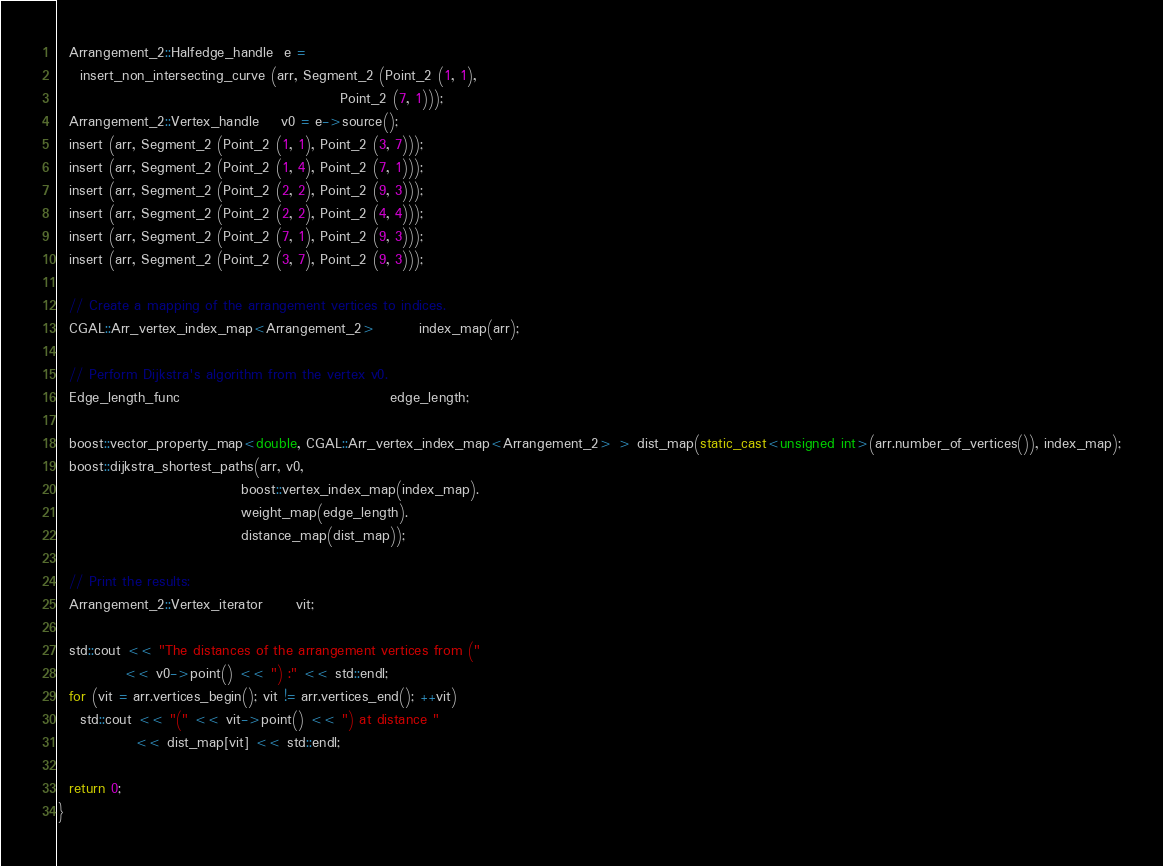<code> <loc_0><loc_0><loc_500><loc_500><_C++_>  Arrangement_2::Halfedge_handle  e =
    insert_non_intersecting_curve (arr, Segment_2 (Point_2 (1, 1),
                                                   Point_2 (7, 1)));
  Arrangement_2::Vertex_handle    v0 = e->source();
  insert (arr, Segment_2 (Point_2 (1, 1), Point_2 (3, 7)));
  insert (arr, Segment_2 (Point_2 (1, 4), Point_2 (7, 1)));
  insert (arr, Segment_2 (Point_2 (2, 2), Point_2 (9, 3)));
  insert (arr, Segment_2 (Point_2 (2, 2), Point_2 (4, 4)));
  insert (arr, Segment_2 (Point_2 (7, 1), Point_2 (9, 3)));
  insert (arr, Segment_2 (Point_2 (3, 7), Point_2 (9, 3)));

  // Create a mapping of the arrangement vertices to indices.
  CGAL::Arr_vertex_index_map<Arrangement_2>        index_map(arr);

  // Perform Dijkstra's algorithm from the vertex v0.
  Edge_length_func                                      edge_length;

  boost::vector_property_map<double, CGAL::Arr_vertex_index_map<Arrangement_2> > dist_map(static_cast<unsigned int>(arr.number_of_vertices()), index_map);
  boost::dijkstra_shortest_paths(arr, v0,
                                 boost::vertex_index_map(index_map).
                                 weight_map(edge_length).
                                 distance_map(dist_map));

  // Print the results:
  Arrangement_2::Vertex_iterator      vit;

  std::cout << "The distances of the arrangement vertices from ("
            << v0->point() << ") :" << std::endl;
  for (vit = arr.vertices_begin(); vit != arr.vertices_end(); ++vit)
    std::cout << "(" << vit->point() << ") at distance "
              << dist_map[vit] << std::endl;

  return 0;
}
</code> 